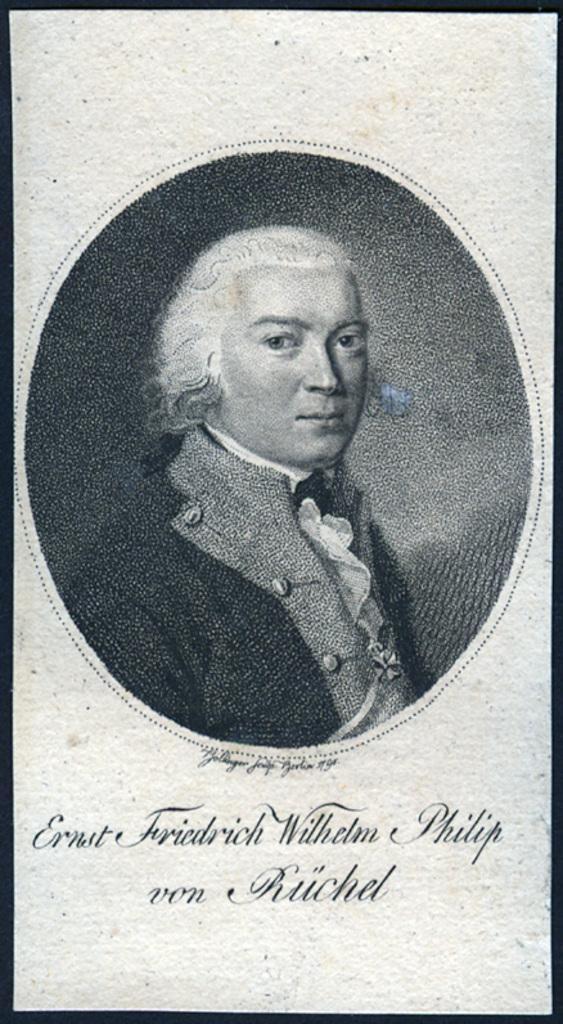Can you describe this image briefly? A poster of a person. Something written on this poster. 